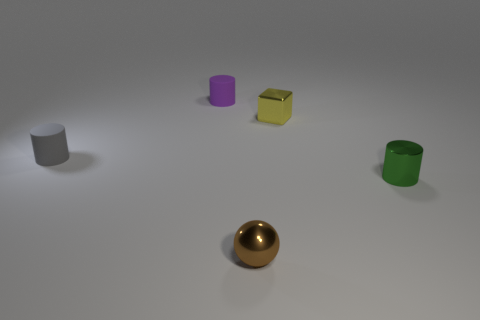Add 1 cylinders. How many objects exist? 6 Subtract all cubes. How many objects are left? 4 Subtract all small brown rubber cylinders. Subtract all green cylinders. How many objects are left? 4 Add 5 metal things. How many metal things are left? 8 Add 3 tiny objects. How many tiny objects exist? 8 Subtract 1 purple cylinders. How many objects are left? 4 